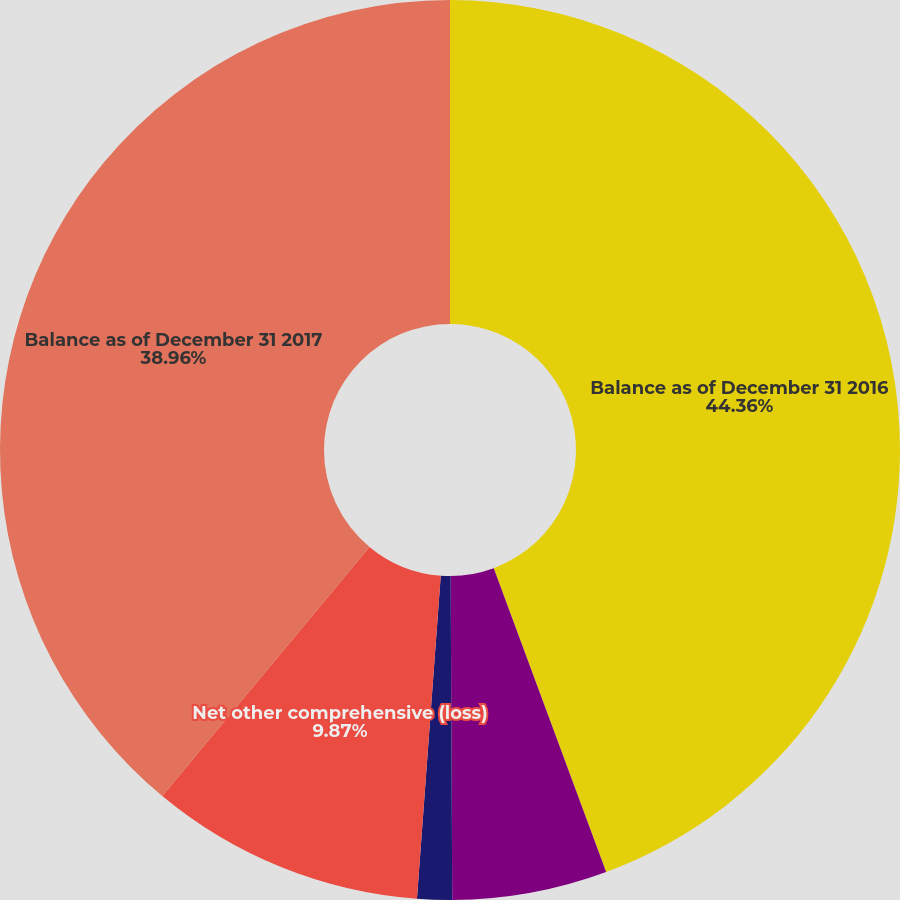Convert chart to OTSL. <chart><loc_0><loc_0><loc_500><loc_500><pie_chart><fcel>Balance as of December 31 2016<fcel>Other comprehensive income<fcel>Amounts reclassified from AOCI<fcel>Net other comprehensive (loss)<fcel>Balance as of December 31 2017<nl><fcel>44.36%<fcel>5.56%<fcel>1.25%<fcel>9.87%<fcel>38.96%<nl></chart> 